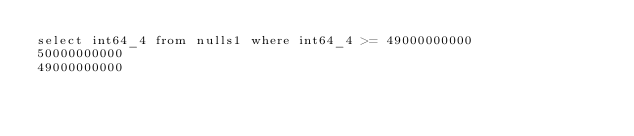Convert code to text. <code><loc_0><loc_0><loc_500><loc_500><_SQL_>select int64_4 from nulls1 where int64_4 >= 49000000000
50000000000
49000000000
</code> 